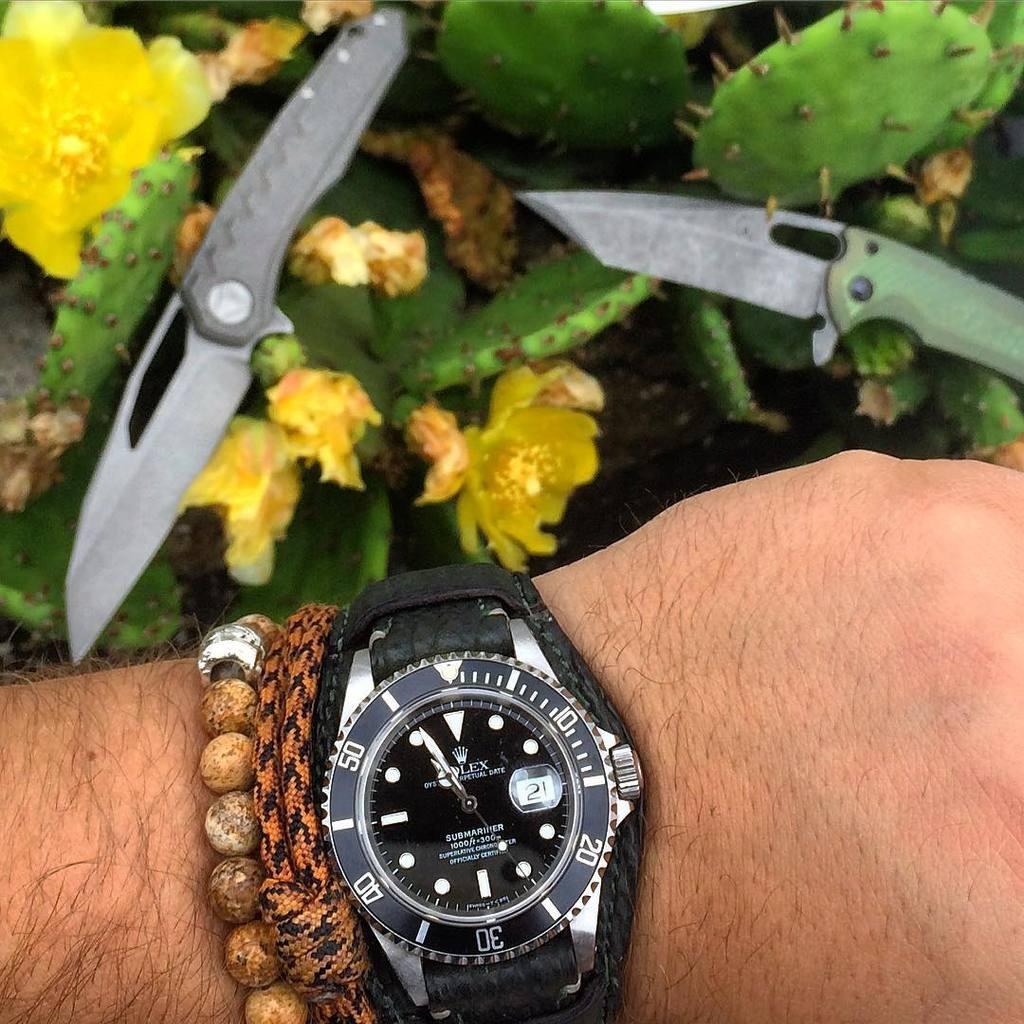<image>
Render a clear and concise summary of the photo. Person wearing a watch that has the number 21 on the screen. 